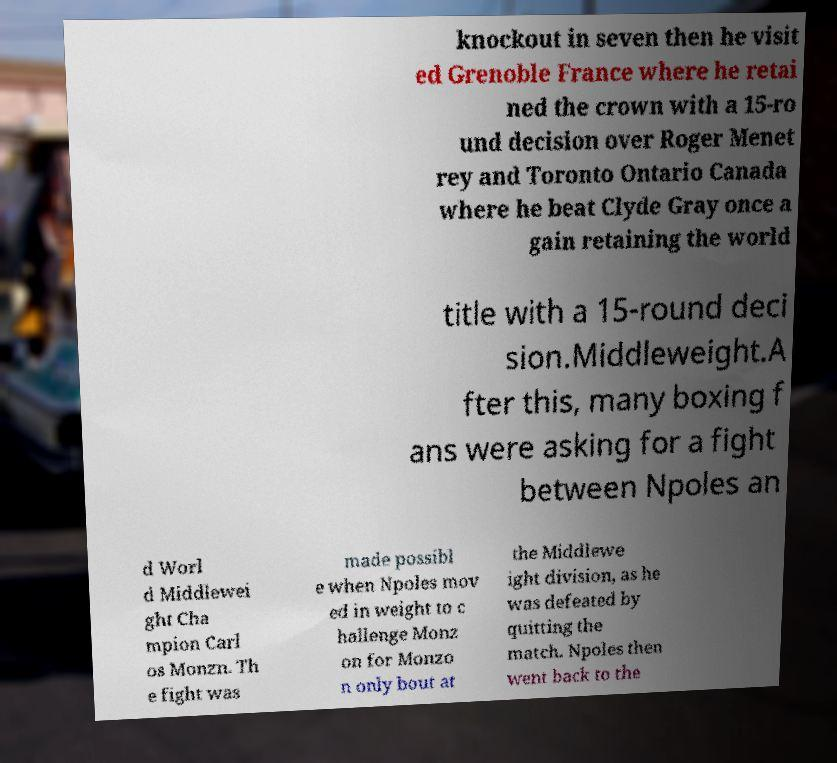Could you assist in decoding the text presented in this image and type it out clearly? knockout in seven then he visit ed Grenoble France where he retai ned the crown with a 15-ro und decision over Roger Menet rey and Toronto Ontario Canada where he beat Clyde Gray once a gain retaining the world title with a 15-round deci sion.Middleweight.A fter this, many boxing f ans were asking for a fight between Npoles an d Worl d Middlewei ght Cha mpion Carl os Monzn. Th e fight was made possibl e when Npoles mov ed in weight to c hallenge Monz on for Monzo n only bout at the Middlewe ight division, as he was defeated by quitting the match. Npoles then went back to the 